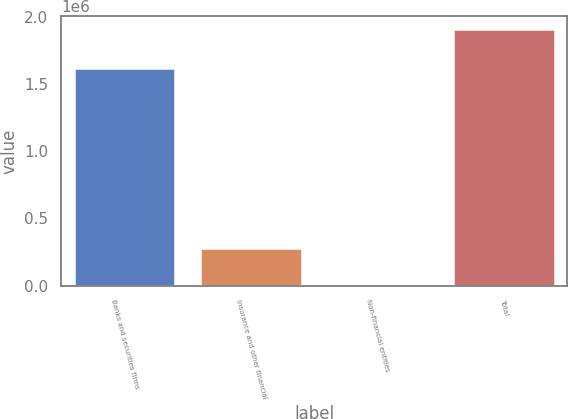<chart> <loc_0><loc_0><loc_500><loc_500><bar_chart><fcel>Banks and securities firms<fcel>Insurance and other financial<fcel>Non-financial entities<fcel>Total<nl><fcel>1.62077e+06<fcel>278705<fcel>7922<fcel>1.9074e+06<nl></chart> 